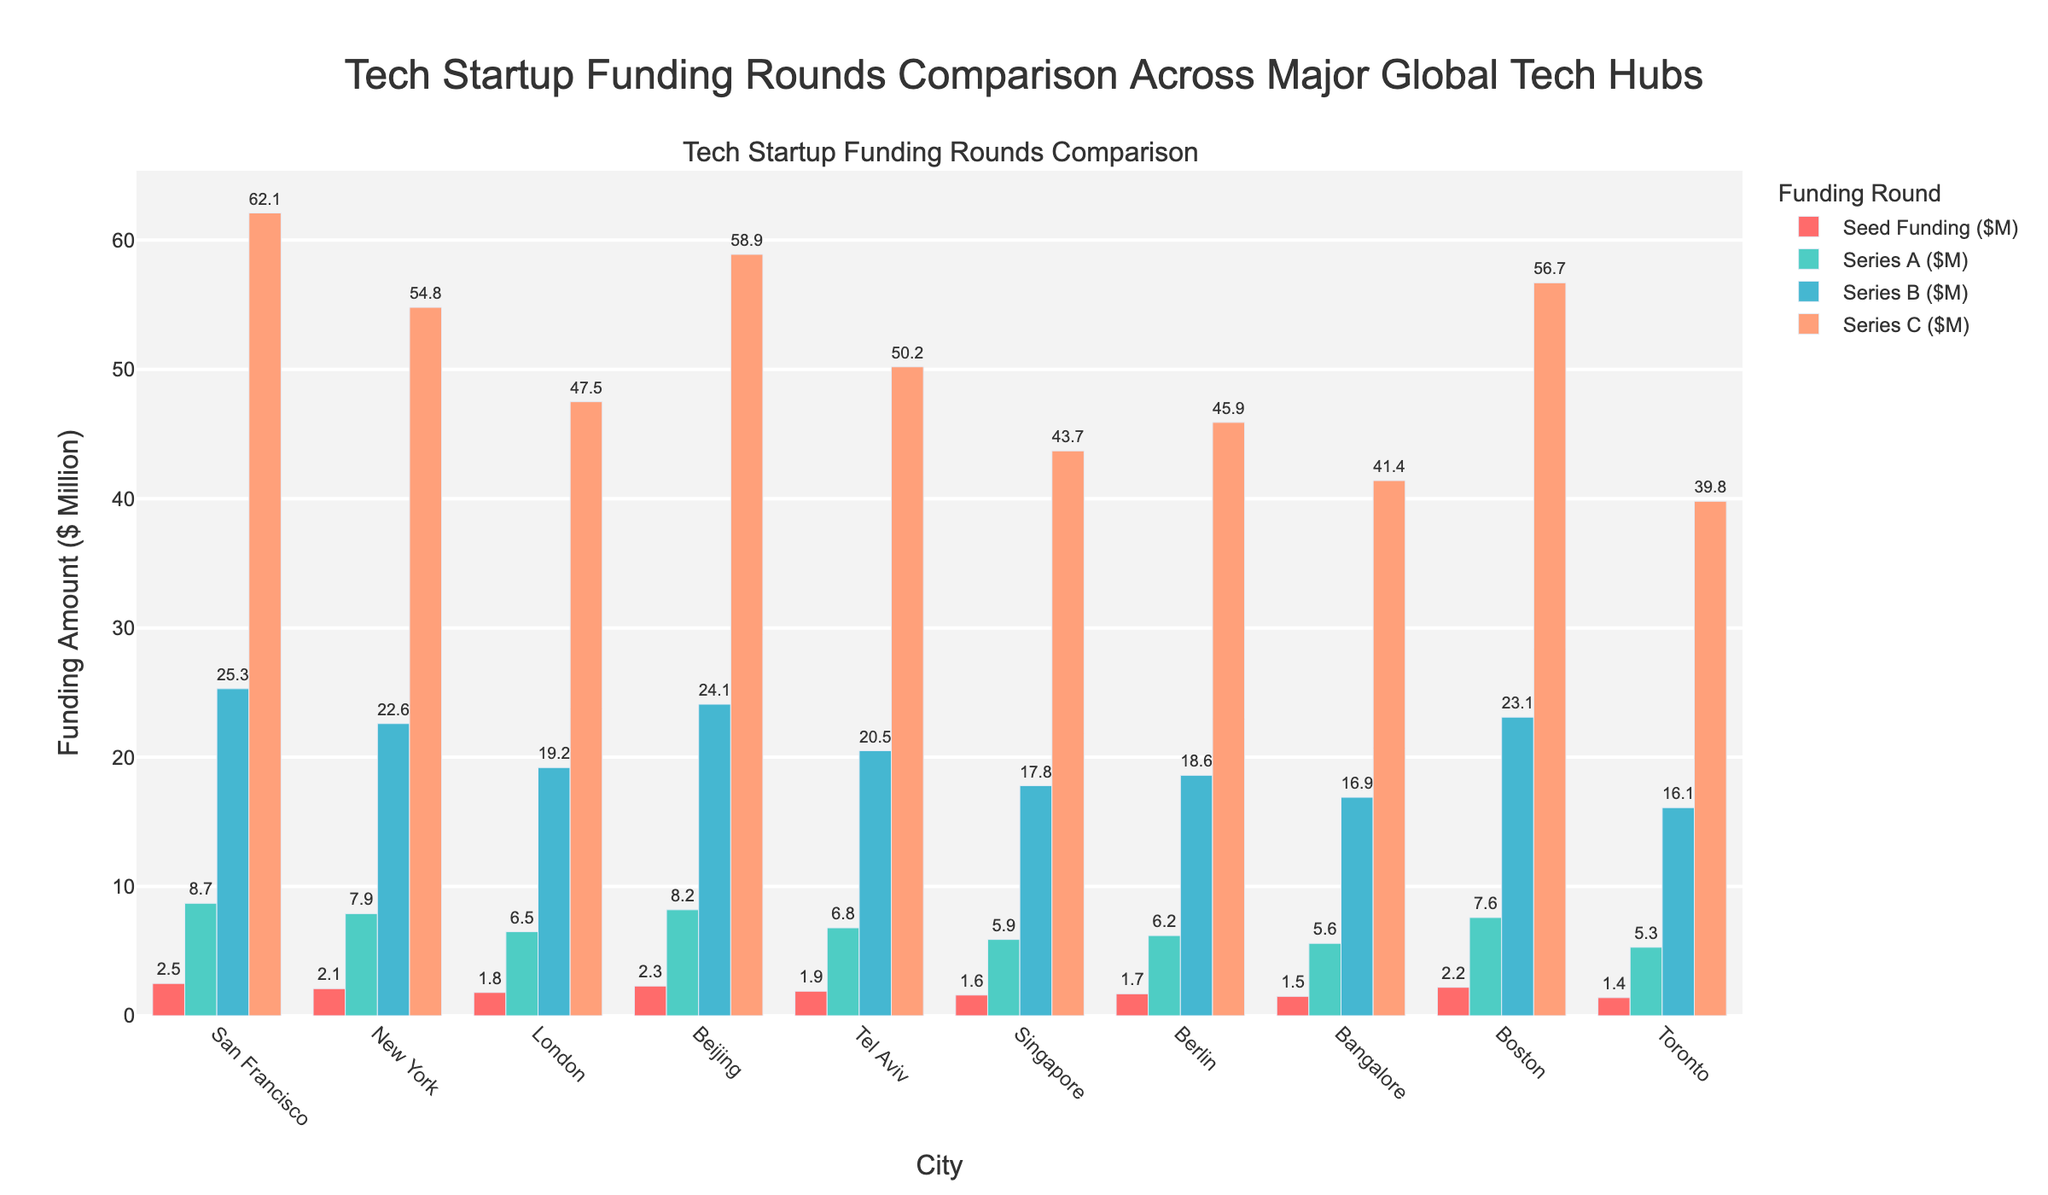What's the total amount of Series A funding across all cities? Add the Series A funding for all the cities: 8.7 (SF) + 7.9 (NY) + 6.5 (London) + 8.2 (Beijing) + 6.8 (Tel Aviv) + 5.9 (Singapore) + 6.2 (Berlin) + 5.6 (Bangalore) + 7.6 (Boston) + 5.3 (Toronto) = 68.7
Answer: 68.7 Which city has the highest Seed funding? Compare the heights of the Seed funding bars for all cities. San Francisco has the highest bar at 2.5.
Answer: San Francisco Is the Series C funding in Beijing greater than in Boston? Compare the Series C bars for Beijing and Boston. Beijing's Series C funding is 58.9, and Boston's is 56.7. Since 58.9 > 56.7, Beijing's is greater.
Answer: Yes Which two cities have the closest amount of Series B funding? Compare the Series B funding amounts and find the pair with the smallest difference. Beijing has 24.1 and San Francisco has 25.3, with a difference of 1.2. This is the smallest difference among all pairs.
Answer: San Francisco and Beijing What's the average Seed funding for cities outside of the USA? Add the Seed funding amounts for London (1.8), Beijing (2.3), Tel Aviv (1.9), Singapore (1.6), Berlin (1.7), Bangalore (1.5), and Toronto (1.4). The total is 12.2. The number of cities is 7, so the average is 12.2 / 7 = 1.74
Answer: 1.74 What is the difference in Series B funding between the highest and the lowest funded cities? The highest Series B funding is San Francisco at 25.3, and the lowest is Toronto at 16.1. The difference is 25.3 - 16.1 = 9.2
Answer: 9.2 Which city has the smallest gap between Series A and Series B funding? Calculate the difference between Series A and Series B for each city. The smallest difference is for Bangalore (Series B 16.9 - Series A 5.6 = 11.3)
Answer: Bangalore In which funding stage is San Francisco most ahead compared to other cities? Compare the bars for each stage across cities. The largest visual difference is seen in Series C, where San Francisco has a significantly higher value (62.1).
Answer: Series C What's the combined funding amount for New York in Seed and Series A rounds? Add the Seed and Series A amounts for New York: 2.1 + 7.9 = 10.0
Answer: 10.0 How does London compare to Berlin in total funding across all rounds? Sum up the total funding for London: 1.8 + 6.5 + 19.2 + 47.5 = 75. Sum up the total funding for Berlin: 1.7 + 6.2 + 18.6 + 45.9 = 72.4. London has more.
Answer: London has more 